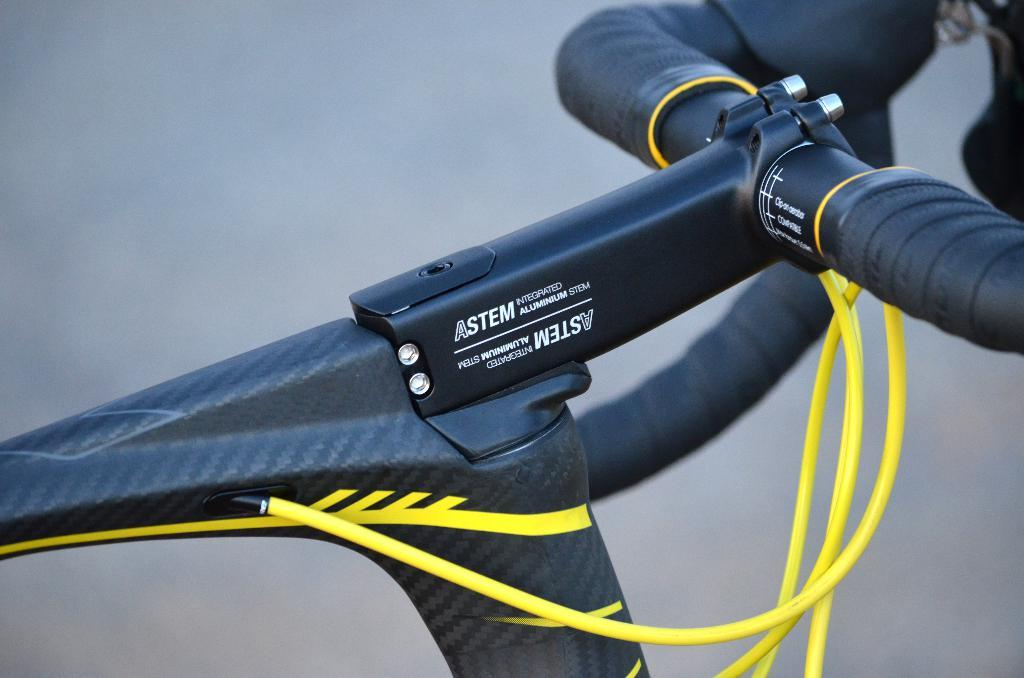What is the main subject in the center of the image? There is an object in the center of the image that appears to be part of a bicycle. What can be seen on the object? There is text on the object. What else can be seen in the image besides the object? There are other objects visible in the background of the image. Can you tell me how many pencils are being used to touch the object in the image? There are no pencils visible in the image, and the object is not being touched by any pencils. What type of meal is being prepared in the background of the image? There is no meal preparation visible in the image; the focus is on the object in the center and the other objects in the background. 